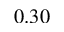Convert formula to latex. <formula><loc_0><loc_0><loc_500><loc_500>0 . 3 0</formula> 